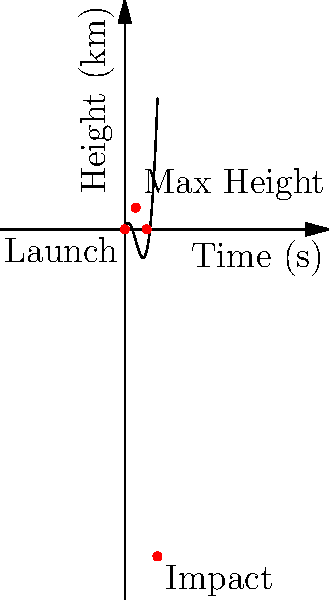A medium-range ballistic missile is launched, and its trajectory is modeled using the cubic function $h(t) = 0.1t^3 - 1.5t^2 + 4t$, where $h$ is the height in kilometers and $t$ is the time in seconds. Based on this model and the graph:

1) At what time does the missile reach its maximum height?
2) What is the maximum height reached by the missile?
3) At what time does the missile impact the ground?

How might the accuracy of this model affect strategic defense planning and non-proliferation efforts? To solve this problem, we need to analyze the cubic function $h(t) = 0.1t^3 - 1.5t^2 + 4t$ and its graph.

1) Maximum height time:
   The maximum height occurs when the derivative $h'(t) = 0$.
   $h'(t) = 0.3t^2 - 3t + 4$
   Setting this to zero: $0.3t^2 - 3t + 4 = 0$
   Solving this quadratic equation gives $t = 5$ seconds.

2) Maximum height:
   Substitute $t = 5$ into the original function:
   $h(5) = 0.1(5^3) - 1.5(5^2) + 4(5) = 12.5 - 37.5 + 20 = 10$ km

3) Impact time:
   The missile impacts when $h(t) = 0$. From the graph, we can see this occurs at $t = 15$ seconds.

Strategic implications:
This model provides crucial information for both offensive and defensive military planning. The accuracy of such models directly affects the effectiveness of missile defense systems and the credibility of deterrence strategies. Inaccuracies could lead to miscalculations in non-proliferation negotiations, as the perceived threat level might be under or overestimated. Furthermore, the ability to accurately model missile trajectories could influence arms control treaties and verification mechanisms.
Answer: 1) 5 seconds
2) 10 km
3) 15 seconds 